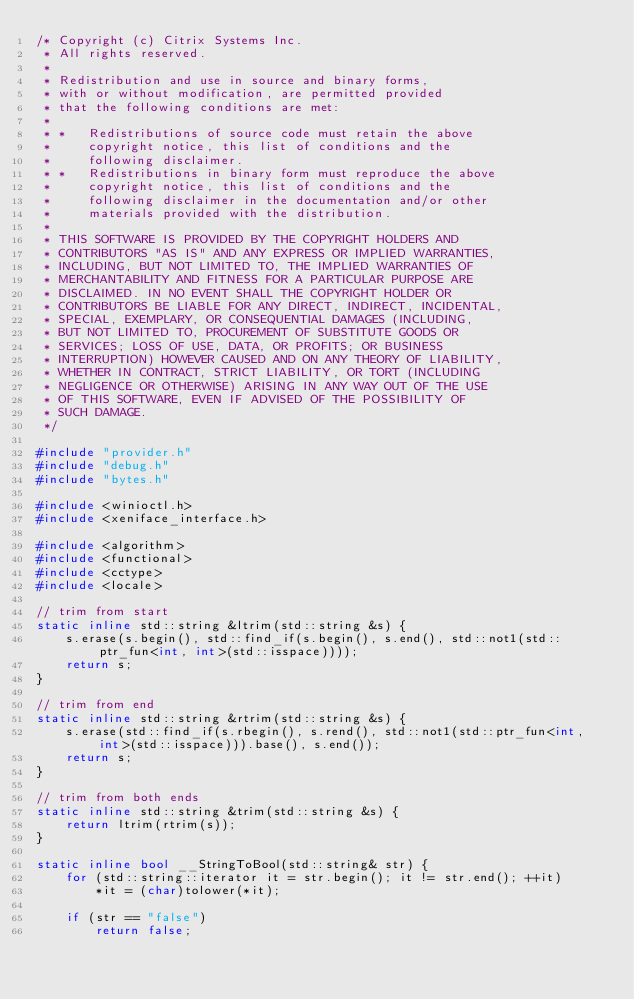Convert code to text. <code><loc_0><loc_0><loc_500><loc_500><_C++_>/* Copyright (c) Citrix Systems Inc.
 * All rights reserved.
 * 
 * Redistribution and use in source and binary forms, 
 * with or without modification, are permitted provided 
 * that the following conditions are met:
 * 
 * *   Redistributions of source code must retain the above 
 *     copyright notice, this list of conditions and the 
 *     following disclaimer.
 * *   Redistributions in binary form must reproduce the above 
 *     copyright notice, this list of conditions and the 
 *     following disclaimer in the documentation and/or other 
 *     materials provided with the distribution.
 * 
 * THIS SOFTWARE IS PROVIDED BY THE COPYRIGHT HOLDERS AND 
 * CONTRIBUTORS "AS IS" AND ANY EXPRESS OR IMPLIED WARRANTIES, 
 * INCLUDING, BUT NOT LIMITED TO, THE IMPLIED WARRANTIES OF 
 * MERCHANTABILITY AND FITNESS FOR A PARTICULAR PURPOSE ARE 
 * DISCLAIMED. IN NO EVENT SHALL THE COPYRIGHT HOLDER OR 
 * CONTRIBUTORS BE LIABLE FOR ANY DIRECT, INDIRECT, INCIDENTAL, 
 * SPECIAL, EXEMPLARY, OR CONSEQUENTIAL DAMAGES (INCLUDING, 
 * BUT NOT LIMITED TO, PROCUREMENT OF SUBSTITUTE GOODS OR 
 * SERVICES; LOSS OF USE, DATA, OR PROFITS; OR BUSINESS 
 * INTERRUPTION) HOWEVER CAUSED AND ON ANY THEORY OF LIABILITY, 
 * WHETHER IN CONTRACT, STRICT LIABILITY, OR TORT (INCLUDING 
 * NEGLIGENCE OR OTHERWISE) ARISING IN ANY WAY OUT OF THE USE 
 * OF THIS SOFTWARE, EVEN IF ADVISED OF THE POSSIBILITY OF 
 * SUCH DAMAGE.
 */

#include "provider.h"
#include "debug.h"
#include "bytes.h"

#include <winioctl.h>
#include <xeniface_interface.h>

#include <algorithm> 
#include <functional>
#include <cctype>
#include <locale>

// trim from start
static inline std::string &ltrim(std::string &s) {
    s.erase(s.begin(), std::find_if(s.begin(), s.end(), std::not1(std::ptr_fun<int, int>(std::isspace))));
    return s;
}

// trim from end
static inline std::string &rtrim(std::string &s) {
    s.erase(std::find_if(s.rbegin(), s.rend(), std::not1(std::ptr_fun<int, int>(std::isspace))).base(), s.end());
    return s;
}

// trim from both ends
static inline std::string &trim(std::string &s) {
    return ltrim(rtrim(s));
}

static inline bool __StringToBool(std::string& str) {
    for (std::string::iterator it = str.begin(); it != str.end(); ++it)
        *it = (char)tolower(*it);

    if (str == "false")
        return false;</code> 